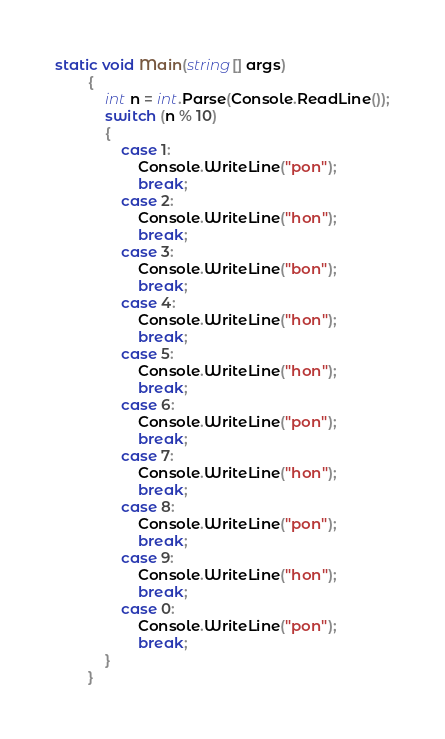Convert code to text. <code><loc_0><loc_0><loc_500><loc_500><_C#_>static void Main(string[] args)
        {
            int n = int.Parse(Console.ReadLine());
            switch (n % 10)
            {
                case 1:
                    Console.WriteLine("pon");
                    break;
                case 2:
                    Console.WriteLine("hon");
                    break;
                case 3:
                    Console.WriteLine("bon");
                    break;
                case 4:
                    Console.WriteLine("hon");
                    break;
                case 5:
                    Console.WriteLine("hon");
                    break;
                case 6:
                    Console.WriteLine("pon");
                    break;
                case 7:
                    Console.WriteLine("hon");
                    break;
                case 8:
                    Console.WriteLine("pon");
                    break;
                case 9:
                    Console.WriteLine("hon");
                    break;
                case 0:
                    Console.WriteLine("pon");
                    break;
            }
        }</code> 